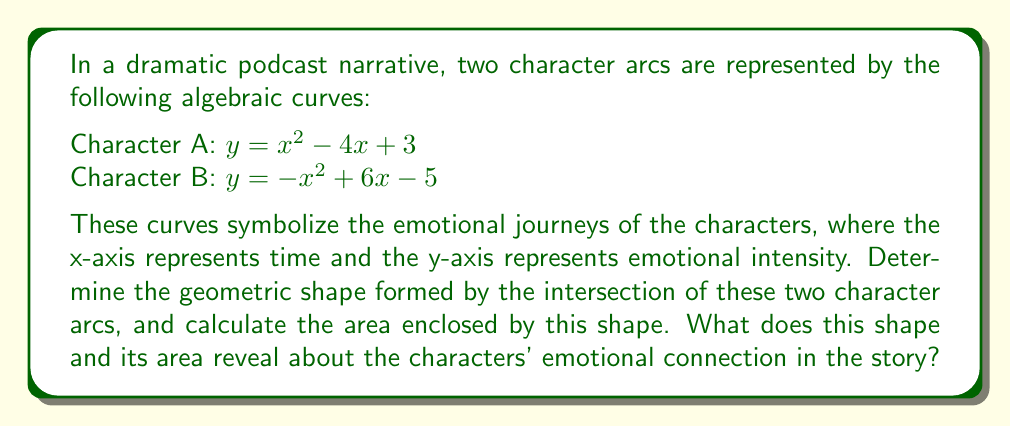Provide a solution to this math problem. To solve this problem, we'll follow these steps:

1. Find the points of intersection between the two curves.
2. Identify the geometric shape formed by these intersection points.
3. Calculate the area of the shape.
4. Interpret the result in the context of the story.

Step 1: Find the points of intersection

To find the intersection points, we set the equations equal to each other:

$$x^2 - 4x + 3 = -x^2 + 6x - 5$$

Rearranging the terms:

$$2x^2 - 10x + 8 = 0$$

Dividing by 2:

$$x^2 - 5x + 4 = 0$$

Using the quadratic formula, $x = \frac{-b \pm \sqrt{b^2 - 4ac}}{2a}$, we get:

$$x = \frac{5 \pm \sqrt{25 - 16}}{2} = \frac{5 \pm 3}{2}$$

So, the x-coordinates of the intersection points are:

$$x_1 = \frac{5 + 3}{2} = 4 \text{ and } x_2 = \frac{5 - 3}{2} = 1$$

Substituting these x-values into either of the original equations gives us the y-coordinates:

For $x_1 = 4$: $y_1 = 4^2 - 4(4) + 3 = 16 - 16 + 3 = 3$
For $x_2 = 1$: $y_2 = 1^2 - 4(1) + 3 = 1 - 4 + 3 = 0$

The intersection points are (1, 0) and (4, 3).

Step 2: Identify the geometric shape

The shape formed by the intersection of these two parabolas is a lens-shaped region, also known as a vesica piscis.

Step 3: Calculate the area

To calculate the area, we need to integrate the difference between the two functions from x = 1 to x = 4:

$$\text{Area} = \int_1^4 [(-x^2 + 6x - 5) - (x^2 - 4x + 3)] dx$$
$$= \int_1^4 (-2x^2 + 10x - 8) dx$$
$$= [-\frac{2}{3}x^3 + 5x^2 - 8x]_1^4$$
$$= [-\frac{2}{3}(64) + 5(16) - 8(4)] - [-\frac{2}{3}(1) + 5(1) - 8(1)]$$
$$= [-\frac{128}{3} + 80 - 32] - [-\frac{2}{3} + 5 - 8]$$
$$= [-\frac{128}{3} + 48] - [-\frac{11}{3}]$$
$$= -\frac{128}{3} + 48 + \frac{11}{3} = \frac{16}{3} \approx 5.33$$

Step 4: Interpret the result

The lens shape (vesica piscis) formed by the intersection of the two character arcs symbolizes the shared emotional space between the characters. The area of this shape (approximately 5.33 units squared) represents the intensity and duration of their emotional connection. The larger the area, the more significant and lasting their interaction is in the story.

The fact that the shape is symmetrical suggests a balanced relationship between the characters, while the pointed ends of the lens indicate moments of heightened emotional intensity at the beginning and end of their interaction.
Answer: Vesica piscis with area $\frac{16}{3}$ square units 